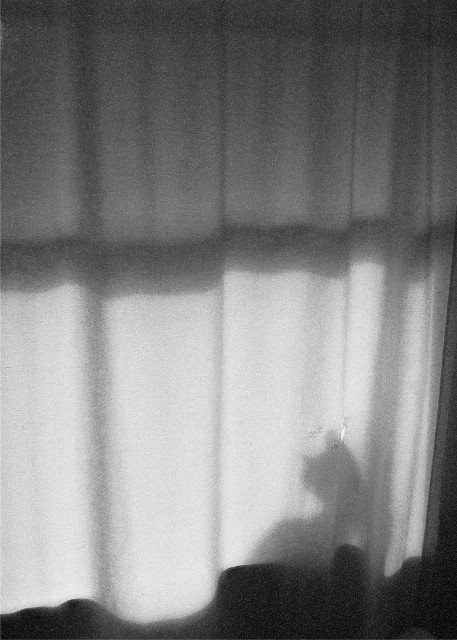What does the shadow on the curtain represent? The shadow appears to be that of a cat, possibly sitting on a windowsill with a strong light source behind it, casting an enlarged and somewhat distorted silhouette on the curtain. Does the image convey a particular mood or atmosphere? Yes, the image evokes a sense of solitude and tranquility, perhaps suggesting a quiet moment in a domestic setting. The softness of the curtain and the gentle curves of the shadow contribute to a peaceful, contemplative atmosphere. 